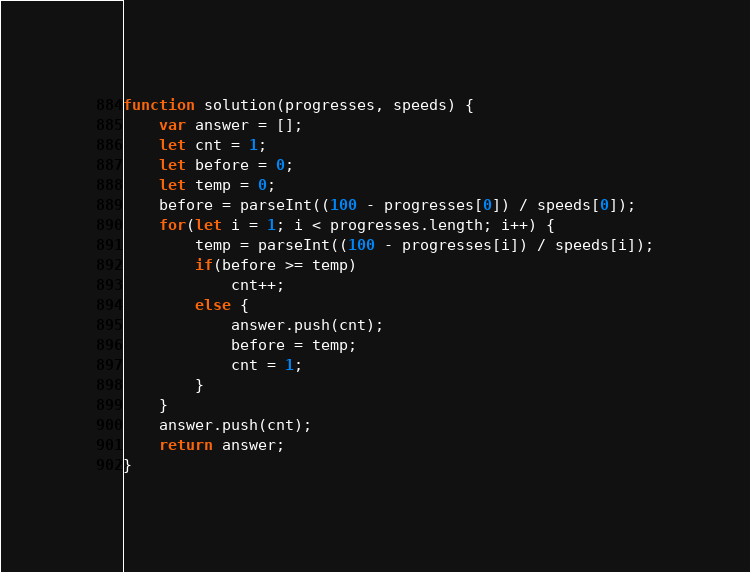Convert code to text. <code><loc_0><loc_0><loc_500><loc_500><_JavaScript_>function solution(progresses, speeds) {
    var answer = [];
    let cnt = 1;
    let before = 0;
    let temp = 0;
    before = parseInt((100 - progresses[0]) / speeds[0]);
    for(let i = 1; i < progresses.length; i++) {
        temp = parseInt((100 - progresses[i]) / speeds[i]);
        if(before >= temp) 
            cnt++;
        else {
            answer.push(cnt);
            before = temp;
            cnt = 1;
        }
    }
    answer.push(cnt);
    return answer;
}</code> 